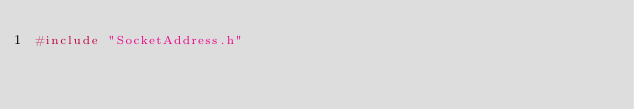Convert code to text. <code><loc_0><loc_0><loc_500><loc_500><_C++_>#include "SocketAddress.h"
</code> 